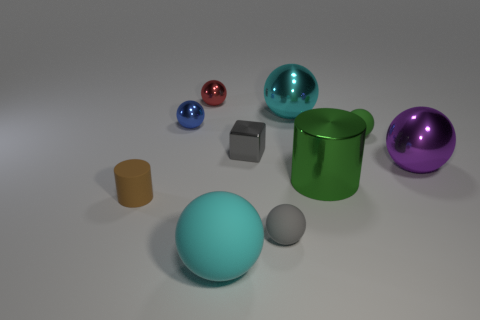What number of things are big metallic things that are to the left of the purple shiny sphere or big spheres that are behind the purple metallic object? In the image, there is one large metallic thing to the left of the purple shiny sphere, which is a blue metallic cube. Additionally, there are no big spheres located behind the purple metallic object. Therefore, the total count of items meeting your criteria is one. 